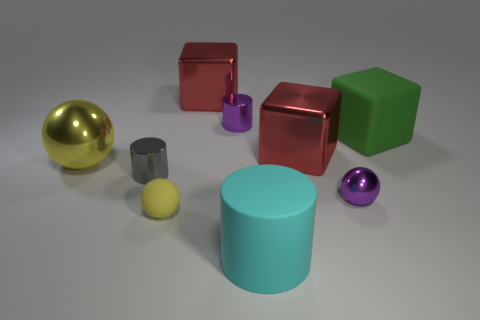Add 1 yellow objects. How many objects exist? 10 Subtract all blocks. How many objects are left? 6 Add 9 tiny yellow balls. How many tiny yellow balls exist? 10 Subtract 0 red cylinders. How many objects are left? 9 Subtract all small gray rubber spheres. Subtract all small gray cylinders. How many objects are left? 8 Add 7 big red cubes. How many big red cubes are left? 9 